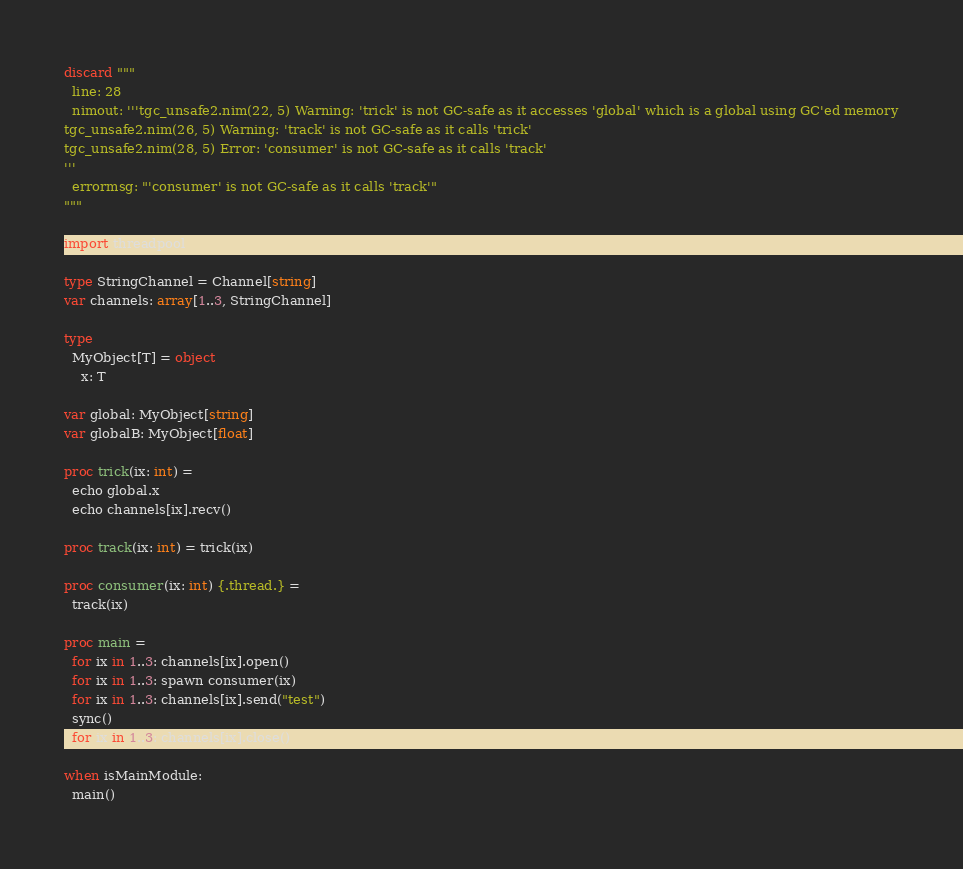Convert code to text. <code><loc_0><loc_0><loc_500><loc_500><_Nim_>discard """
  line: 28
  nimout: '''tgc_unsafe2.nim(22, 5) Warning: 'trick' is not GC-safe as it accesses 'global' which is a global using GC'ed memory
tgc_unsafe2.nim(26, 5) Warning: 'track' is not GC-safe as it calls 'trick'
tgc_unsafe2.nim(28, 5) Error: 'consumer' is not GC-safe as it calls 'track'
'''
  errormsg: "'consumer' is not GC-safe as it calls 'track'"
"""

import threadpool

type StringChannel = Channel[string]
var channels: array[1..3, StringChannel]

type
  MyObject[T] = object
    x: T

var global: MyObject[string]
var globalB: MyObject[float]

proc trick(ix: int) =
  echo global.x
  echo channels[ix].recv()

proc track(ix: int) = trick(ix)

proc consumer(ix: int) {.thread.} =
  track(ix)

proc main =
  for ix in 1..3: channels[ix].open()
  for ix in 1..3: spawn consumer(ix)
  for ix in 1..3: channels[ix].send("test")
  sync()
  for ix in 1..3: channels[ix].close()

when isMainModule:
  main()
</code> 